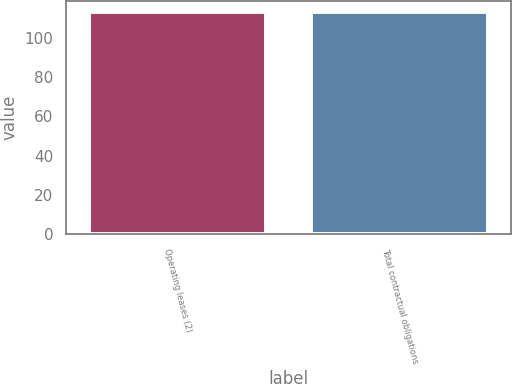<chart> <loc_0><loc_0><loc_500><loc_500><bar_chart><fcel>Operating leases (2)<fcel>Total contractual obligations<nl><fcel>113<fcel>113.1<nl></chart> 